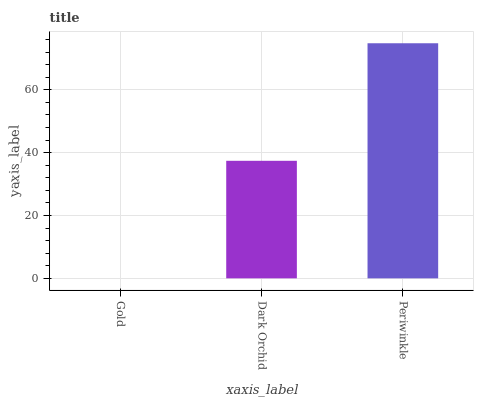Is Gold the minimum?
Answer yes or no. Yes. Is Periwinkle the maximum?
Answer yes or no. Yes. Is Dark Orchid the minimum?
Answer yes or no. No. Is Dark Orchid the maximum?
Answer yes or no. No. Is Dark Orchid greater than Gold?
Answer yes or no. Yes. Is Gold less than Dark Orchid?
Answer yes or no. Yes. Is Gold greater than Dark Orchid?
Answer yes or no. No. Is Dark Orchid less than Gold?
Answer yes or no. No. Is Dark Orchid the high median?
Answer yes or no. Yes. Is Dark Orchid the low median?
Answer yes or no. Yes. Is Gold the high median?
Answer yes or no. No. Is Periwinkle the low median?
Answer yes or no. No. 